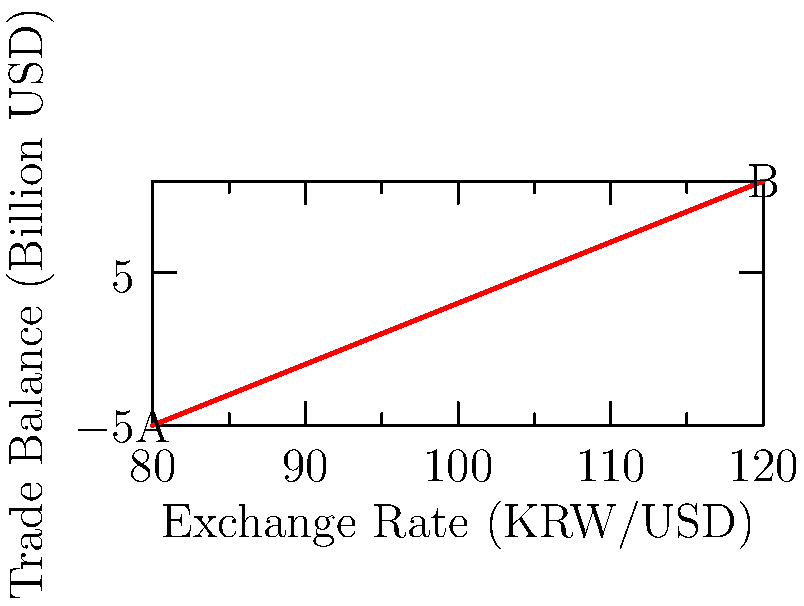The scatter plot shows the relationship between the exchange rate (KRW/USD) and South Korea's trade balance (in billion USD) over a period of time. Based on the trend observed in the plot, what can be inferred about the impact of a weakening Korean Won on the country's trade balance? How might this affect South Korea's dependency on foreign capital? To answer this question, let's analyze the scatter plot step-by-step:

1. Observe the trend: As we move from point A to point B, we can see that as the exchange rate increases (KRW weakens against USD), the trade balance improves (increases).

2. Interpret the relationship: This positive correlation suggests that a weaker Korean Won (higher KRW/USD rate) is associated with an improving trade balance.

3. Economic reasoning:
   a) A weaker Won makes Korean exports cheaper in foreign markets, potentially increasing demand for Korean goods.
   b) Simultaneously, imports become more expensive for Korean consumers, potentially reducing import demand.
   c) The combination of increased exports and decreased imports leads to an improved trade balance.

4. Impact on foreign capital dependency:
   a) An improving trade balance means more foreign currency earnings from exports.
   b) This could reduce the need for foreign capital inflows to finance imports or cover trade deficits.
   c) Over time, this may help decrease South Korea's dependency on foreign capital.

5. Considerations:
   a) While a weaker currency may benefit the trade balance, it could have other economic implications (e.g., inflation, purchasing power).
   b) The relationship observed is a correlation and doesn't necessarily imply causation; other factors may influence the trade balance.

Therefore, based on the scatter plot, a weakening Korean Won appears to be associated with an improving trade balance, which could potentially reduce South Korea's dependency on foreign capital in the long run.
Answer: A weakening Won improves trade balance, potentially reducing foreign capital dependency. 